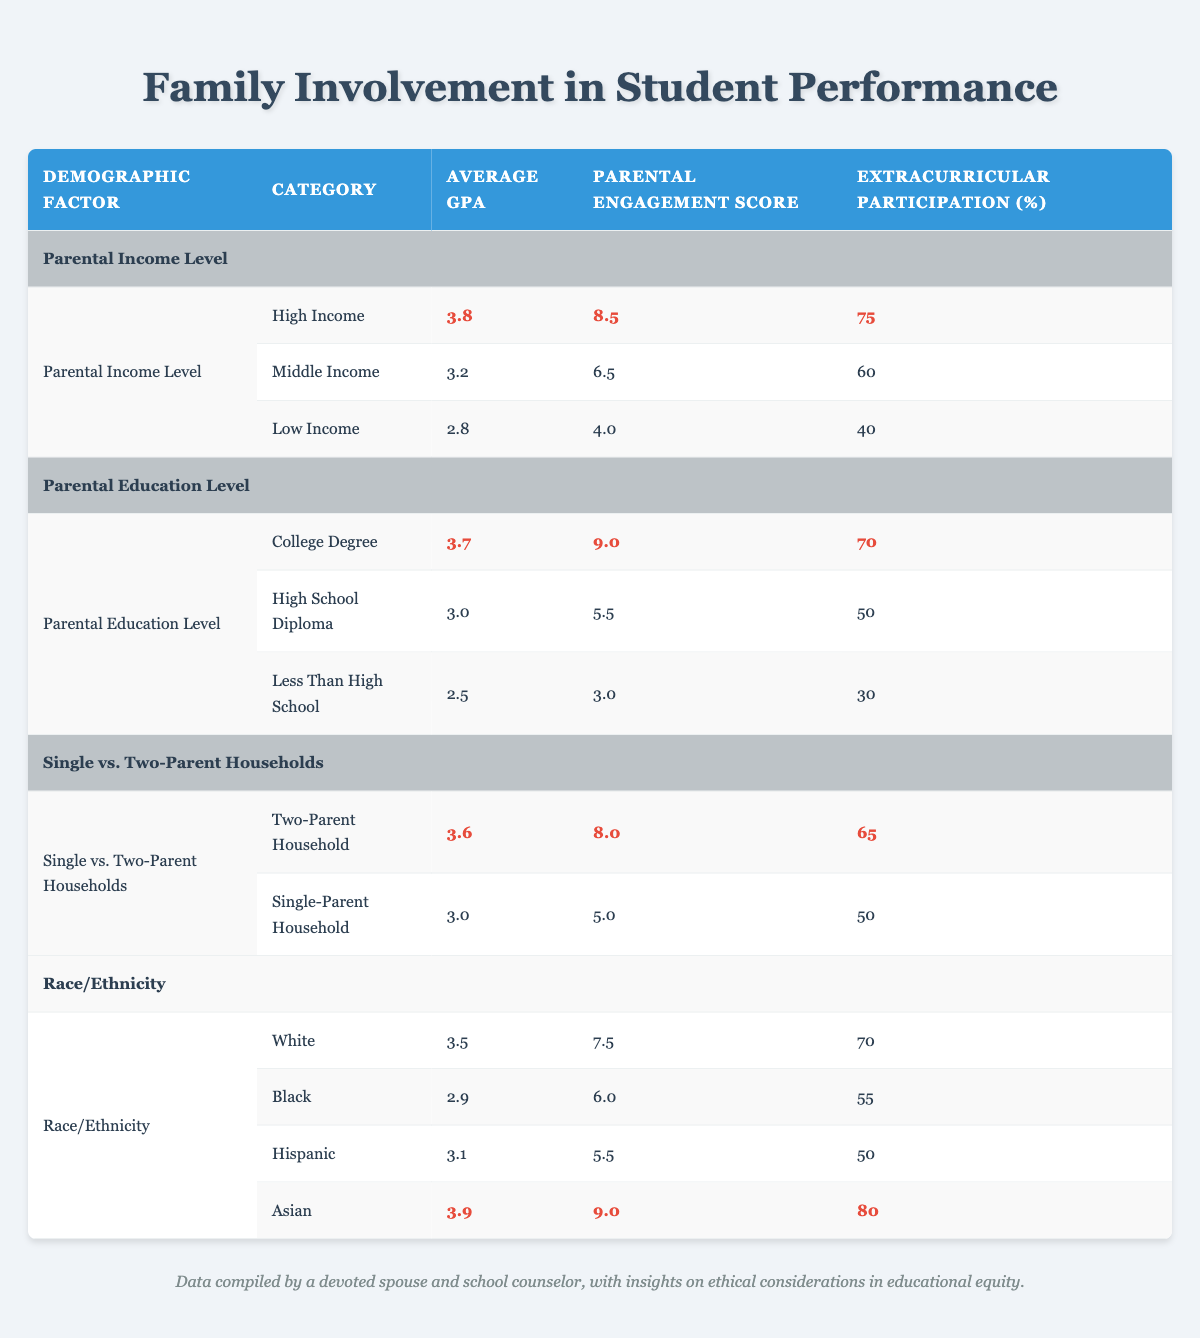What is the Average GPA for students from High Income families? The table shows the Average GPA for different income levels. For High Income, the Average GPA is explicitly listed as 3.8.
Answer: 3.8 What is the Parental Engagement Score for families with parents who hold a College Degree? According to the table, the Parental Engagement Score for the College Degree category is stated as 9.0.
Answer: 9.0 Which group has the lowest Extracurricular Participation percentage? By comparing the Extracurricular Participation percentages for all groups, Low Income families have 40%, which is the lowest among the listed demographics.
Answer: Low Income True or False: The Average GPA of students in Asian households is higher than that of students in White households. The Average GPA for Asian households is 3.9, while for White households, it is 3.5. Since 3.9 is greater than 3.5, the statement is true.
Answer: True What is the difference in Average GPA between Two-Parent and Single-Parent households? The Average GPA for Two-Parent households is 3.6 and for Single-Parent households is 3.0. To find the difference, subtract the Single-Parent GPA from the Two-Parent GPA: 3.6 - 3.0 = 0.6.
Answer: 0.6 What is the average Extracurricular Participation percentage across all Parental Education Levels? To calculate the average, we sum the Extracurricular Participation percentages (70 + 50 + 30) = 150 and then divide by the number of groups (3): 150 / 3 = 50.
Answer: 50 How many demographic categories have an Average GPA above 3.0? Looking through the Average GPA values, we identify those above 3.0: High Income (3.8), College Degree (3.7), Two-Parent (3.6), White (3.5), and Asian (3.9). This makes a total of 5 groups.
Answer: 5 What is the average Parental Engagement Score for the Low Income and Single-Parent categories combined? The Parental Engagement Score for Low Income is 4.0, and for Single-Parent households, it is 5.0. To calculate: (4.0 + 5.0) / 2 = 4.5.
Answer: 4.5 True or False: The average Extracurricular Participation value for students in Hispanic households is higher than that for students in Black households. The Extracurricular Participation for Hispanic is 50% while for Black, it is 55%. Since 50% is not higher than 55%, the statement is false.
Answer: False 